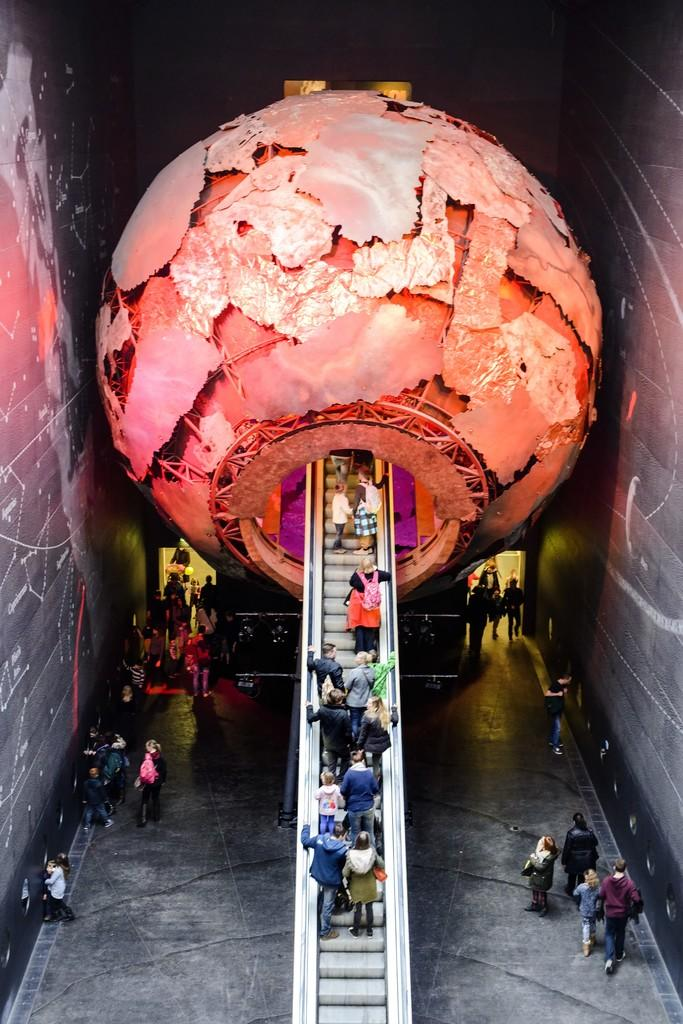What is the main object in the middle of the picture? There is a sphere in the middle of the picture. What architectural feature is also present in the middle of the picture? There is a staircase in the middle of the picture. What can be seen on the floor on either side of the picture? There are people on the floor on either side of the picture. How would you describe the lighting in the image? The background of the image is dark. What type of destruction can be seen on the roof in the image? There is no roof present in the image, and therefore no destruction can be observed. 